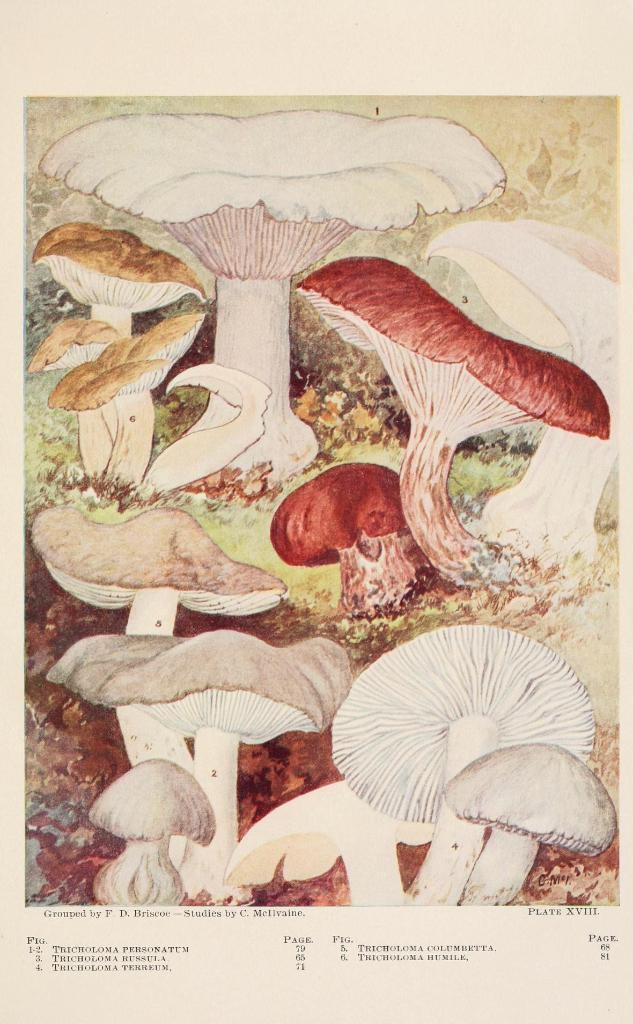What type of visual is the image? The image is a poster. What is depicted in the poster? There are mushrooms in the image. Is there any text present in the image? Yes, there is text written at the bottom of the image. What color is the sweater worn by the mushroom in the image? There are no mushrooms wearing sweaters in the image, as mushrooms do not wear clothing. 